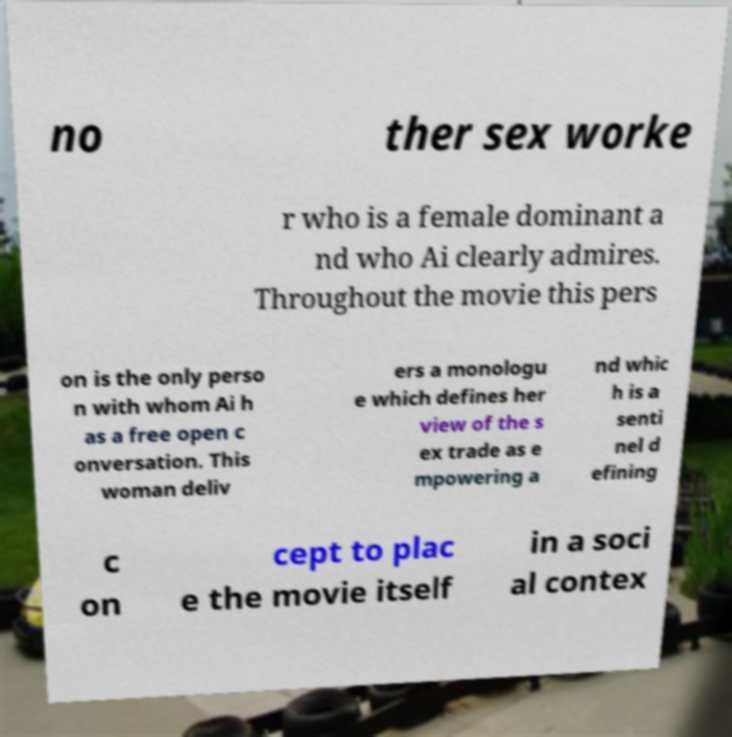For documentation purposes, I need the text within this image transcribed. Could you provide that? no ther sex worke r who is a female dominant a nd who Ai clearly admires. Throughout the movie this pers on is the only perso n with whom Ai h as a free open c onversation. This woman deliv ers a monologu e which defines her view of the s ex trade as e mpowering a nd whic h is a senti nel d efining c on cept to plac e the movie itself in a soci al contex 